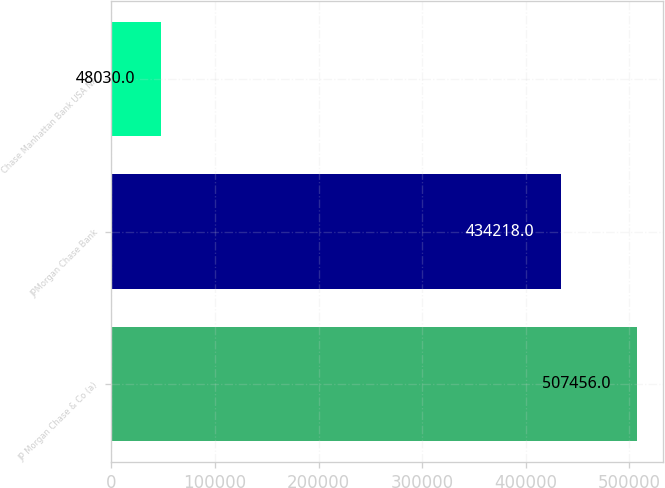<chart> <loc_0><loc_0><loc_500><loc_500><bar_chart><fcel>JP Morgan Chase & Co (a)<fcel>JPMorgan Chase Bank<fcel>Chase Manhattan Bank USA NA<nl><fcel>507456<fcel>434218<fcel>48030<nl></chart> 